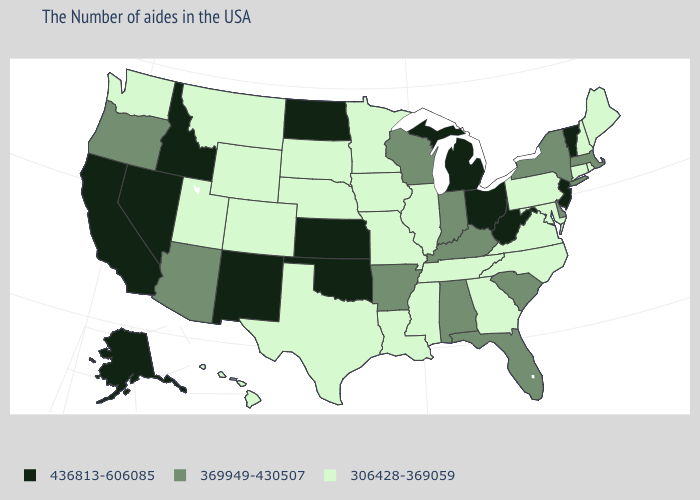Name the states that have a value in the range 306428-369059?
Write a very short answer. Maine, Rhode Island, New Hampshire, Connecticut, Maryland, Pennsylvania, Virginia, North Carolina, Georgia, Tennessee, Illinois, Mississippi, Louisiana, Missouri, Minnesota, Iowa, Nebraska, Texas, South Dakota, Wyoming, Colorado, Utah, Montana, Washington, Hawaii. Name the states that have a value in the range 369949-430507?
Quick response, please. Massachusetts, New York, Delaware, South Carolina, Florida, Kentucky, Indiana, Alabama, Wisconsin, Arkansas, Arizona, Oregon. What is the value of Maine?
Quick response, please. 306428-369059. What is the highest value in the USA?
Answer briefly. 436813-606085. What is the value of Montana?
Give a very brief answer. 306428-369059. Does Oklahoma have the highest value in the USA?
Keep it brief. Yes. Among the states that border Connecticut , which have the highest value?
Keep it brief. Massachusetts, New York. Does Washington have a lower value than Florida?
Concise answer only. Yes. Name the states that have a value in the range 369949-430507?
Quick response, please. Massachusetts, New York, Delaware, South Carolina, Florida, Kentucky, Indiana, Alabama, Wisconsin, Arkansas, Arizona, Oregon. Name the states that have a value in the range 306428-369059?
Keep it brief. Maine, Rhode Island, New Hampshire, Connecticut, Maryland, Pennsylvania, Virginia, North Carolina, Georgia, Tennessee, Illinois, Mississippi, Louisiana, Missouri, Minnesota, Iowa, Nebraska, Texas, South Dakota, Wyoming, Colorado, Utah, Montana, Washington, Hawaii. Does Tennessee have a lower value than New Mexico?
Be succinct. Yes. Does the map have missing data?
Write a very short answer. No. Does Hawaii have the lowest value in the West?
Concise answer only. Yes. Among the states that border Nevada , does Utah have the lowest value?
Write a very short answer. Yes. Name the states that have a value in the range 306428-369059?
Answer briefly. Maine, Rhode Island, New Hampshire, Connecticut, Maryland, Pennsylvania, Virginia, North Carolina, Georgia, Tennessee, Illinois, Mississippi, Louisiana, Missouri, Minnesota, Iowa, Nebraska, Texas, South Dakota, Wyoming, Colorado, Utah, Montana, Washington, Hawaii. 